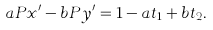<formula> <loc_0><loc_0><loc_500><loc_500>a P x ^ { \prime } - b P y ^ { \prime } = 1 - a t _ { 1 } + b t _ { 2 } .</formula> 